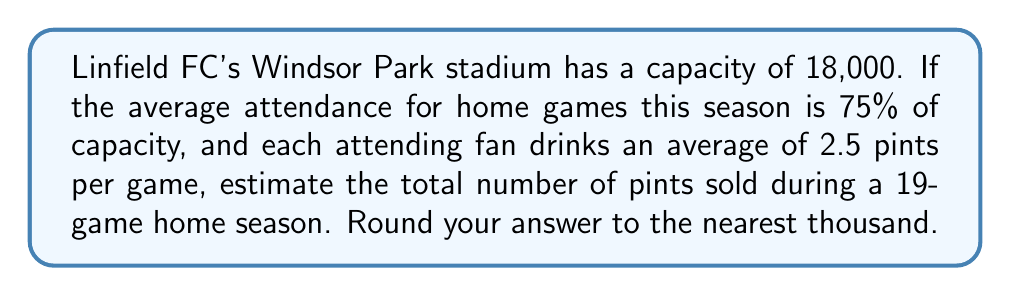Can you solve this math problem? Let's break this down step-by-step:

1. Calculate the average attendance per game:
   $$ \text{Average Attendance} = 18,000 \times 0.75 = 13,500 \text{ fans} $$

2. Calculate the number of pints sold per game:
   $$ \text{Pints per Game} = 13,500 \text{ fans} \times 2.5 \text{ pints/fan} = 33,750 \text{ pints} $$

3. Calculate the total number of pints sold in a 19-game home season:
   $$ \text{Total Pints} = 33,750 \text{ pints/game} \times 19 \text{ games} = 641,250 \text{ pints} $$

4. Round to the nearest thousand:
   $641,250$ rounds to $641,000$
Answer: 641,000 pints 